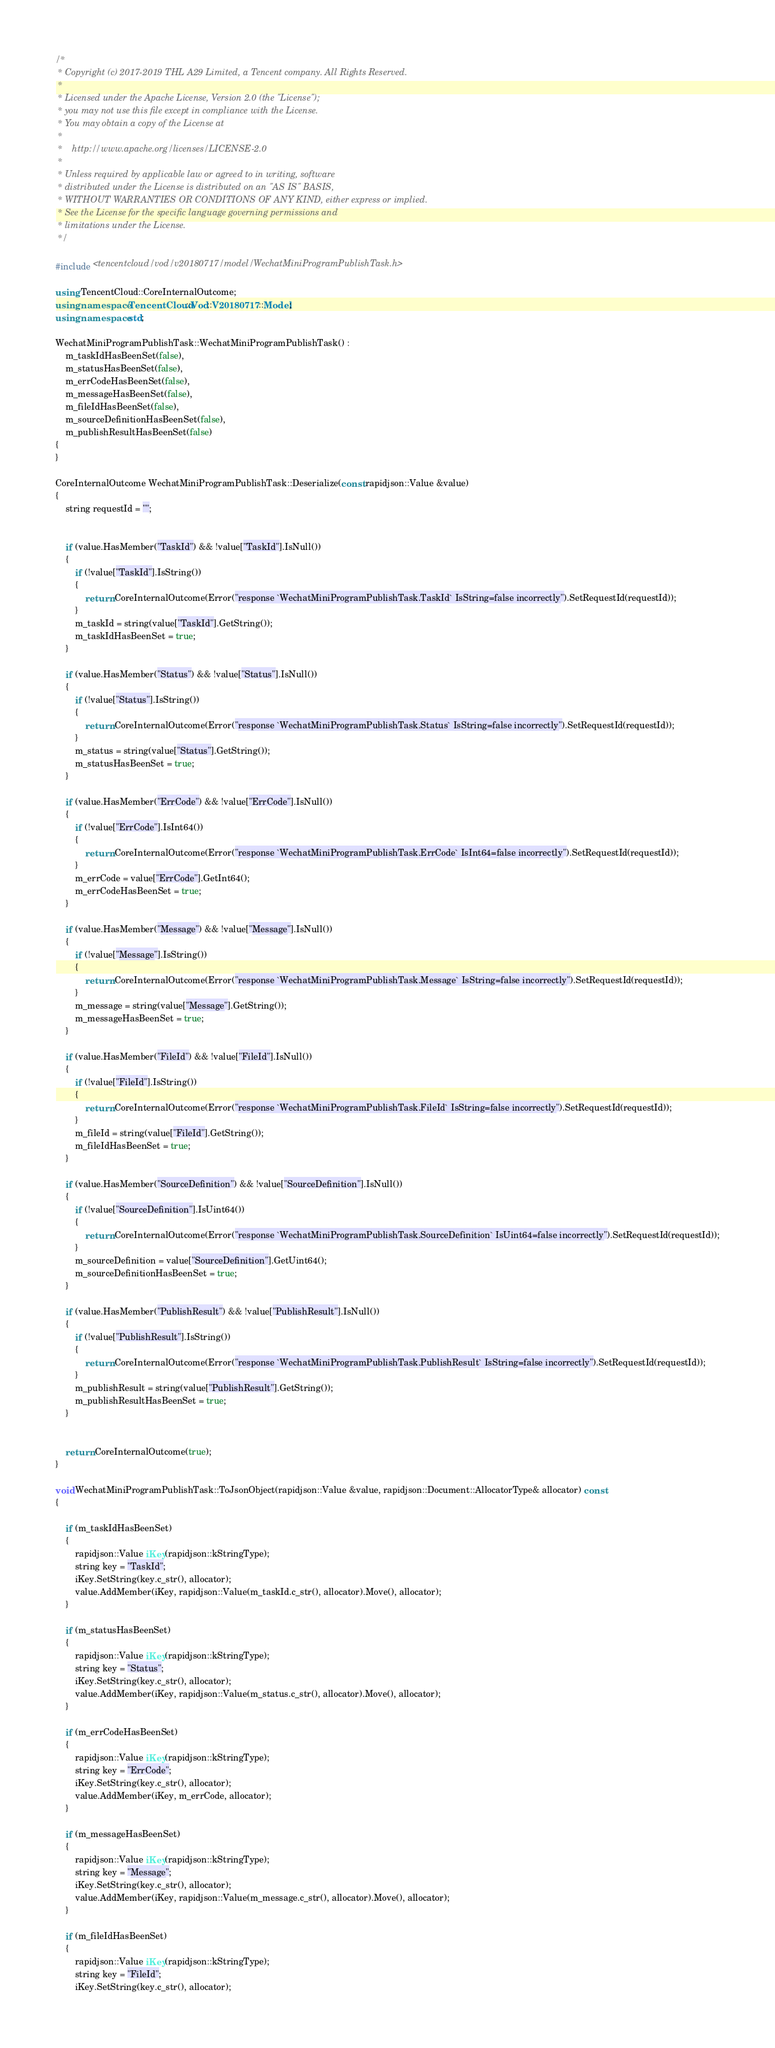Convert code to text. <code><loc_0><loc_0><loc_500><loc_500><_C++_>/*
 * Copyright (c) 2017-2019 THL A29 Limited, a Tencent company. All Rights Reserved.
 *
 * Licensed under the Apache License, Version 2.0 (the "License");
 * you may not use this file except in compliance with the License.
 * You may obtain a copy of the License at
 *
 *    http://www.apache.org/licenses/LICENSE-2.0
 *
 * Unless required by applicable law or agreed to in writing, software
 * distributed under the License is distributed on an "AS IS" BASIS,
 * WITHOUT WARRANTIES OR CONDITIONS OF ANY KIND, either express or implied.
 * See the License for the specific language governing permissions and
 * limitations under the License.
 */

#include <tencentcloud/vod/v20180717/model/WechatMiniProgramPublishTask.h>

using TencentCloud::CoreInternalOutcome;
using namespace TencentCloud::Vod::V20180717::Model;
using namespace std;

WechatMiniProgramPublishTask::WechatMiniProgramPublishTask() :
    m_taskIdHasBeenSet(false),
    m_statusHasBeenSet(false),
    m_errCodeHasBeenSet(false),
    m_messageHasBeenSet(false),
    m_fileIdHasBeenSet(false),
    m_sourceDefinitionHasBeenSet(false),
    m_publishResultHasBeenSet(false)
{
}

CoreInternalOutcome WechatMiniProgramPublishTask::Deserialize(const rapidjson::Value &value)
{
    string requestId = "";


    if (value.HasMember("TaskId") && !value["TaskId"].IsNull())
    {
        if (!value["TaskId"].IsString())
        {
            return CoreInternalOutcome(Error("response `WechatMiniProgramPublishTask.TaskId` IsString=false incorrectly").SetRequestId(requestId));
        }
        m_taskId = string(value["TaskId"].GetString());
        m_taskIdHasBeenSet = true;
    }

    if (value.HasMember("Status") && !value["Status"].IsNull())
    {
        if (!value["Status"].IsString())
        {
            return CoreInternalOutcome(Error("response `WechatMiniProgramPublishTask.Status` IsString=false incorrectly").SetRequestId(requestId));
        }
        m_status = string(value["Status"].GetString());
        m_statusHasBeenSet = true;
    }

    if (value.HasMember("ErrCode") && !value["ErrCode"].IsNull())
    {
        if (!value["ErrCode"].IsInt64())
        {
            return CoreInternalOutcome(Error("response `WechatMiniProgramPublishTask.ErrCode` IsInt64=false incorrectly").SetRequestId(requestId));
        }
        m_errCode = value["ErrCode"].GetInt64();
        m_errCodeHasBeenSet = true;
    }

    if (value.HasMember("Message") && !value["Message"].IsNull())
    {
        if (!value["Message"].IsString())
        {
            return CoreInternalOutcome(Error("response `WechatMiniProgramPublishTask.Message` IsString=false incorrectly").SetRequestId(requestId));
        }
        m_message = string(value["Message"].GetString());
        m_messageHasBeenSet = true;
    }

    if (value.HasMember("FileId") && !value["FileId"].IsNull())
    {
        if (!value["FileId"].IsString())
        {
            return CoreInternalOutcome(Error("response `WechatMiniProgramPublishTask.FileId` IsString=false incorrectly").SetRequestId(requestId));
        }
        m_fileId = string(value["FileId"].GetString());
        m_fileIdHasBeenSet = true;
    }

    if (value.HasMember("SourceDefinition") && !value["SourceDefinition"].IsNull())
    {
        if (!value["SourceDefinition"].IsUint64())
        {
            return CoreInternalOutcome(Error("response `WechatMiniProgramPublishTask.SourceDefinition` IsUint64=false incorrectly").SetRequestId(requestId));
        }
        m_sourceDefinition = value["SourceDefinition"].GetUint64();
        m_sourceDefinitionHasBeenSet = true;
    }

    if (value.HasMember("PublishResult") && !value["PublishResult"].IsNull())
    {
        if (!value["PublishResult"].IsString())
        {
            return CoreInternalOutcome(Error("response `WechatMiniProgramPublishTask.PublishResult` IsString=false incorrectly").SetRequestId(requestId));
        }
        m_publishResult = string(value["PublishResult"].GetString());
        m_publishResultHasBeenSet = true;
    }


    return CoreInternalOutcome(true);
}

void WechatMiniProgramPublishTask::ToJsonObject(rapidjson::Value &value, rapidjson::Document::AllocatorType& allocator) const
{

    if (m_taskIdHasBeenSet)
    {
        rapidjson::Value iKey(rapidjson::kStringType);
        string key = "TaskId";
        iKey.SetString(key.c_str(), allocator);
        value.AddMember(iKey, rapidjson::Value(m_taskId.c_str(), allocator).Move(), allocator);
    }

    if (m_statusHasBeenSet)
    {
        rapidjson::Value iKey(rapidjson::kStringType);
        string key = "Status";
        iKey.SetString(key.c_str(), allocator);
        value.AddMember(iKey, rapidjson::Value(m_status.c_str(), allocator).Move(), allocator);
    }

    if (m_errCodeHasBeenSet)
    {
        rapidjson::Value iKey(rapidjson::kStringType);
        string key = "ErrCode";
        iKey.SetString(key.c_str(), allocator);
        value.AddMember(iKey, m_errCode, allocator);
    }

    if (m_messageHasBeenSet)
    {
        rapidjson::Value iKey(rapidjson::kStringType);
        string key = "Message";
        iKey.SetString(key.c_str(), allocator);
        value.AddMember(iKey, rapidjson::Value(m_message.c_str(), allocator).Move(), allocator);
    }

    if (m_fileIdHasBeenSet)
    {
        rapidjson::Value iKey(rapidjson::kStringType);
        string key = "FileId";
        iKey.SetString(key.c_str(), allocator);</code> 